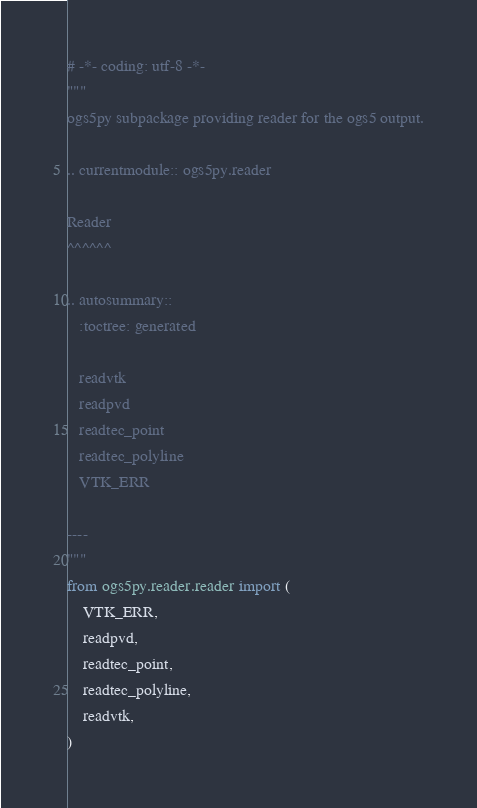Convert code to text. <code><loc_0><loc_0><loc_500><loc_500><_Python_># -*- coding: utf-8 -*-
"""
ogs5py subpackage providing reader for the ogs5 output.

.. currentmodule:: ogs5py.reader

Reader
^^^^^^

.. autosummary::
   :toctree: generated

   readvtk
   readpvd
   readtec_point
   readtec_polyline
   VTK_ERR

----
"""
from ogs5py.reader.reader import (
    VTK_ERR,
    readpvd,
    readtec_point,
    readtec_polyline,
    readvtk,
)
</code> 